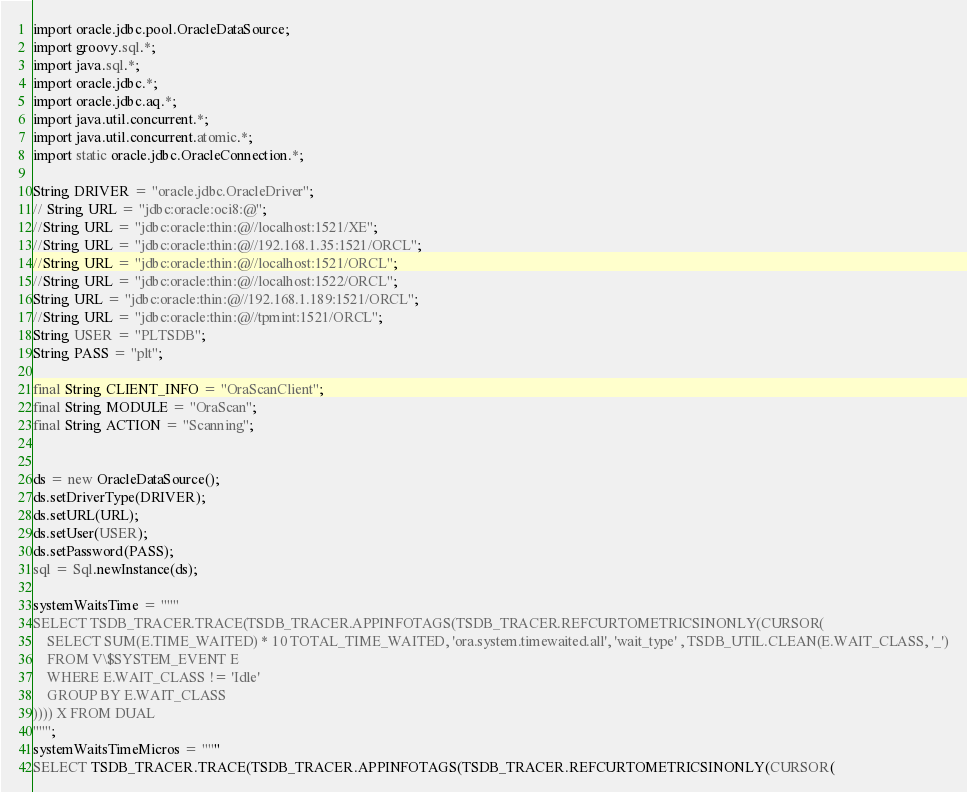Convert code to text. <code><loc_0><loc_0><loc_500><loc_500><_SQL_>import oracle.jdbc.pool.OracleDataSource;
import groovy.sql.*;
import java.sql.*;
import oracle.jdbc.*;
import oracle.jdbc.aq.*;
import java.util.concurrent.*;
import java.util.concurrent.atomic.*;
import static oracle.jdbc.OracleConnection.*;

String DRIVER = "oracle.jdbc.OracleDriver";
// String URL = "jdbc:oracle:oci8:@";
//String URL = "jdbc:oracle:thin:@//localhost:1521/XE";
//String URL = "jdbc:oracle:thin:@//192.168.1.35:1521/ORCL";
//String URL = "jdbc:oracle:thin:@//localhost:1521/ORCL";
//String URL = "jdbc:oracle:thin:@//localhost:1522/ORCL";
String URL = "jdbc:oracle:thin:@//192.168.1.189:1521/ORCL";
//String URL = "jdbc:oracle:thin:@//tpmint:1521/ORCL";
String USER = "PLTSDB";
String PASS = "plt";

final String CLIENT_INFO = "OraScanClient";
final String MODULE = "OraScan";
final String ACTION = "Scanning";


ds = new OracleDataSource();
ds.setDriverType(DRIVER);
ds.setURL(URL);
ds.setUser(USER);
ds.setPassword(PASS);
sql = Sql.newInstance(ds);

systemWaitsTime = """
SELECT TSDB_TRACER.TRACE(TSDB_TRACER.APPINFOTAGS(TSDB_TRACER.REFCURTOMETRICSINONLY(CURSOR(
    SELECT SUM(E.TIME_WAITED) * 10 TOTAL_TIME_WAITED, 'ora.system.timewaited.all', 'wait_type' , TSDB_UTIL.CLEAN(E.WAIT_CLASS, '_')
    FROM V\$SYSTEM_EVENT E
    WHERE E.WAIT_CLASS != 'Idle'
    GROUP BY E.WAIT_CLASS
)))) X FROM DUAL
""";
systemWaitsTimeMicros = """
SELECT TSDB_TRACER.TRACE(TSDB_TRACER.APPINFOTAGS(TSDB_TRACER.REFCURTOMETRICSINONLY(CURSOR(</code> 